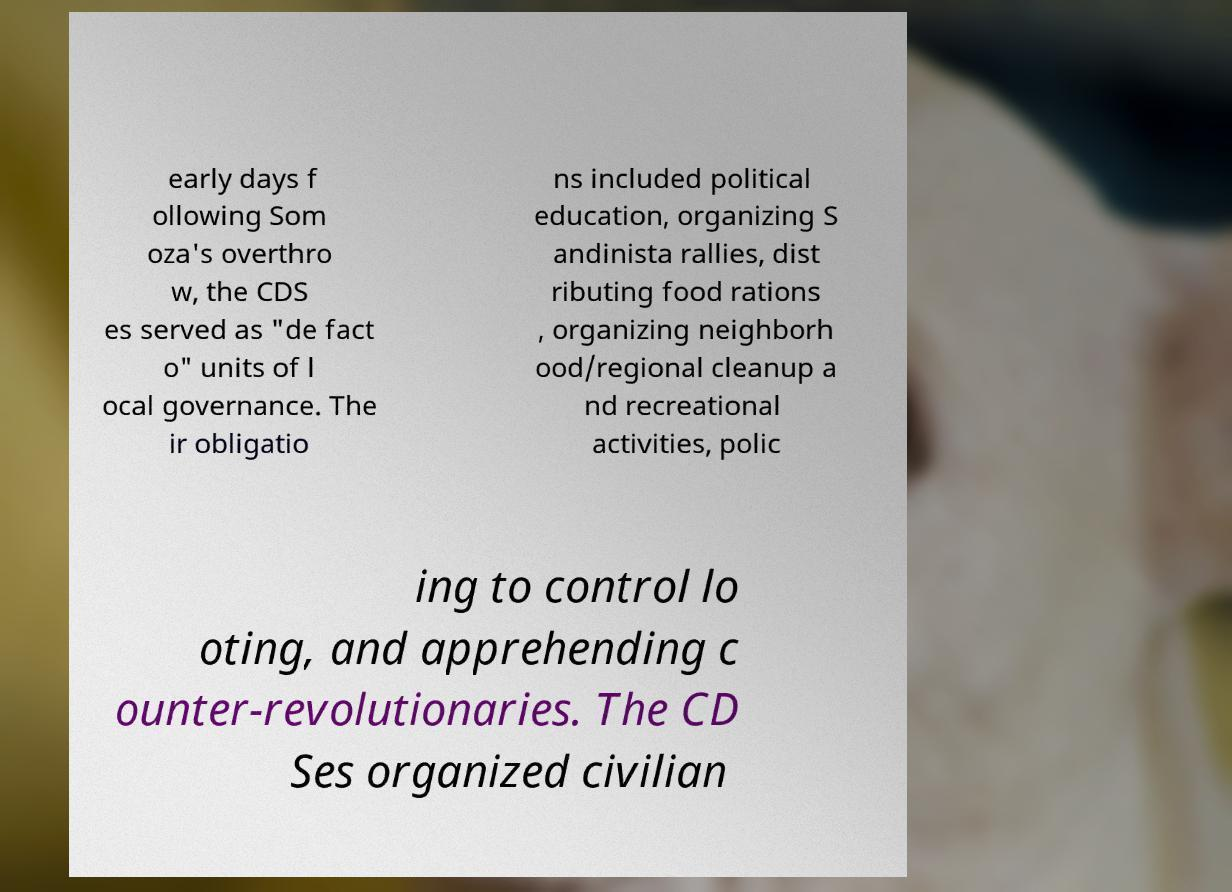Can you read and provide the text displayed in the image?This photo seems to have some interesting text. Can you extract and type it out for me? early days f ollowing Som oza's overthro w, the CDS es served as "de fact o" units of l ocal governance. The ir obligatio ns included political education, organizing S andinista rallies, dist ributing food rations , organizing neighborh ood/regional cleanup a nd recreational activities, polic ing to control lo oting, and apprehending c ounter-revolutionaries. The CD Ses organized civilian 